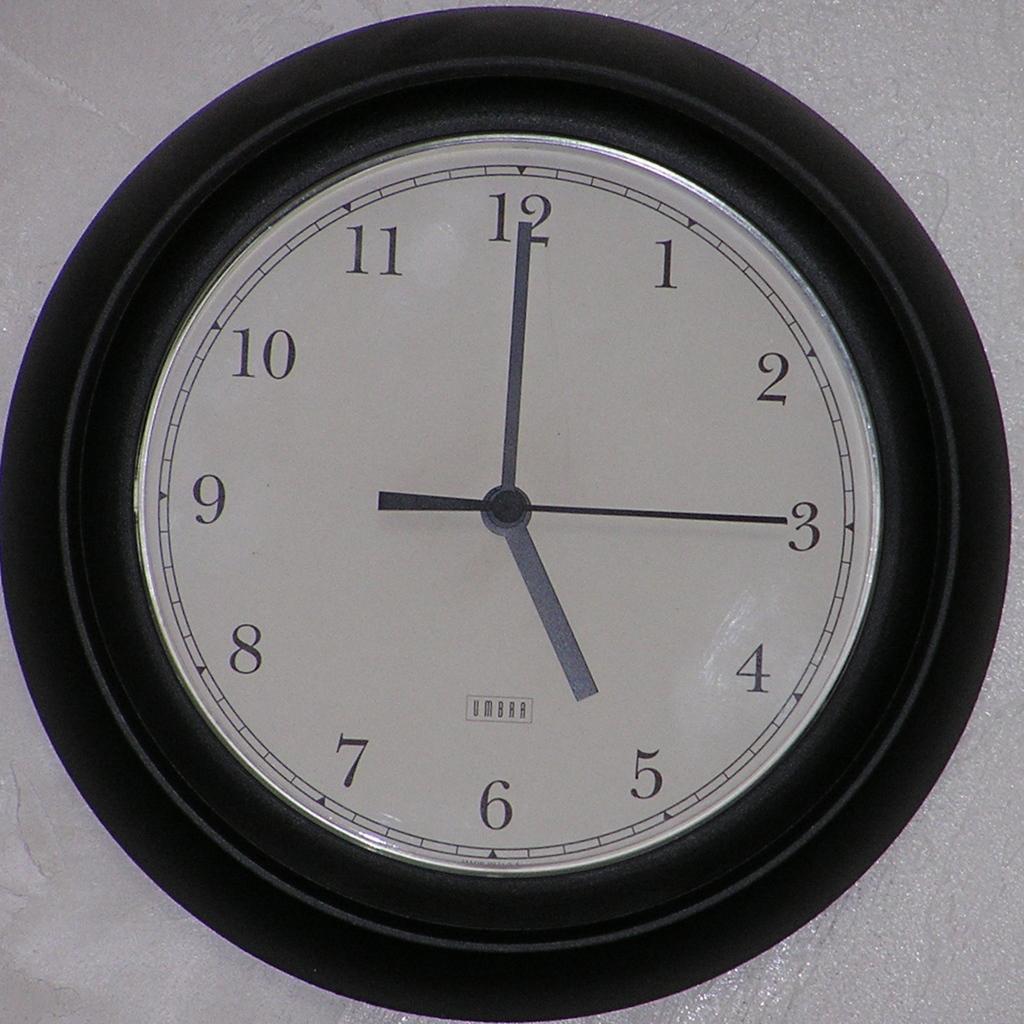What number is the short hand on?
Your answer should be compact. 5. The time on the clock reads?
Ensure brevity in your answer.  5:00. 